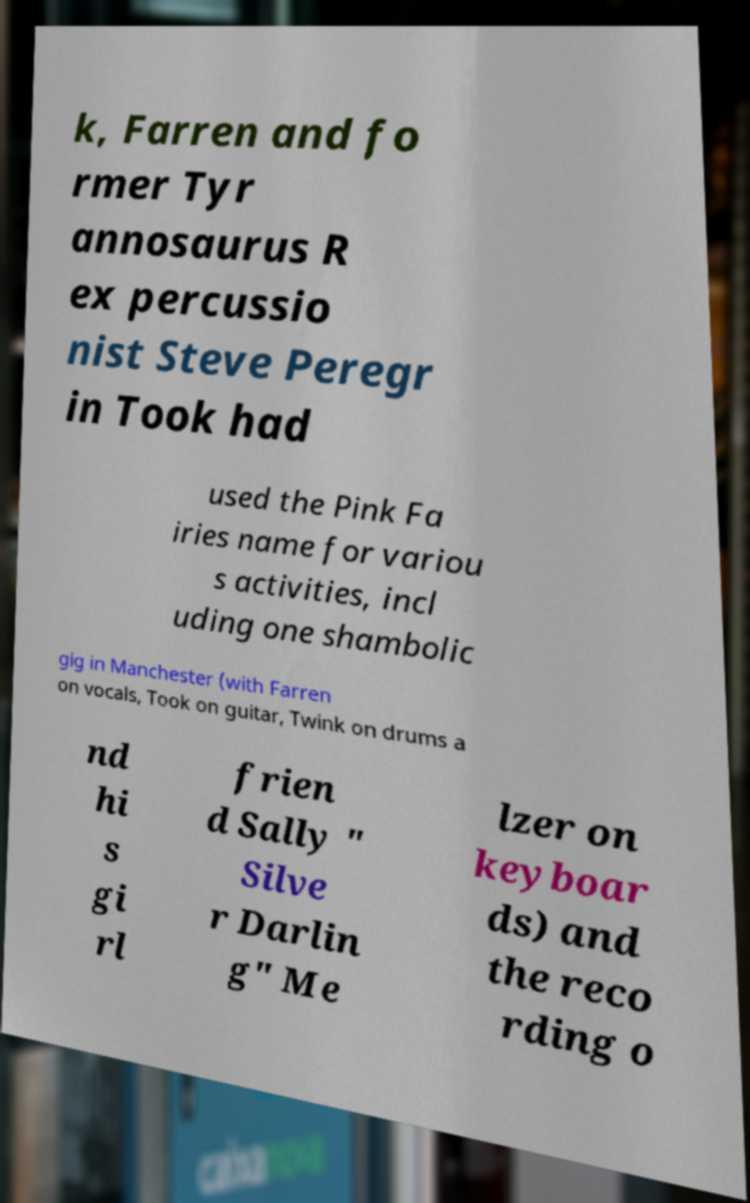I need the written content from this picture converted into text. Can you do that? k, Farren and fo rmer Tyr annosaurus R ex percussio nist Steve Peregr in Took had used the Pink Fa iries name for variou s activities, incl uding one shambolic gig in Manchester (with Farren on vocals, Took on guitar, Twink on drums a nd hi s gi rl frien d Sally " Silve r Darlin g" Me lzer on keyboar ds) and the reco rding o 